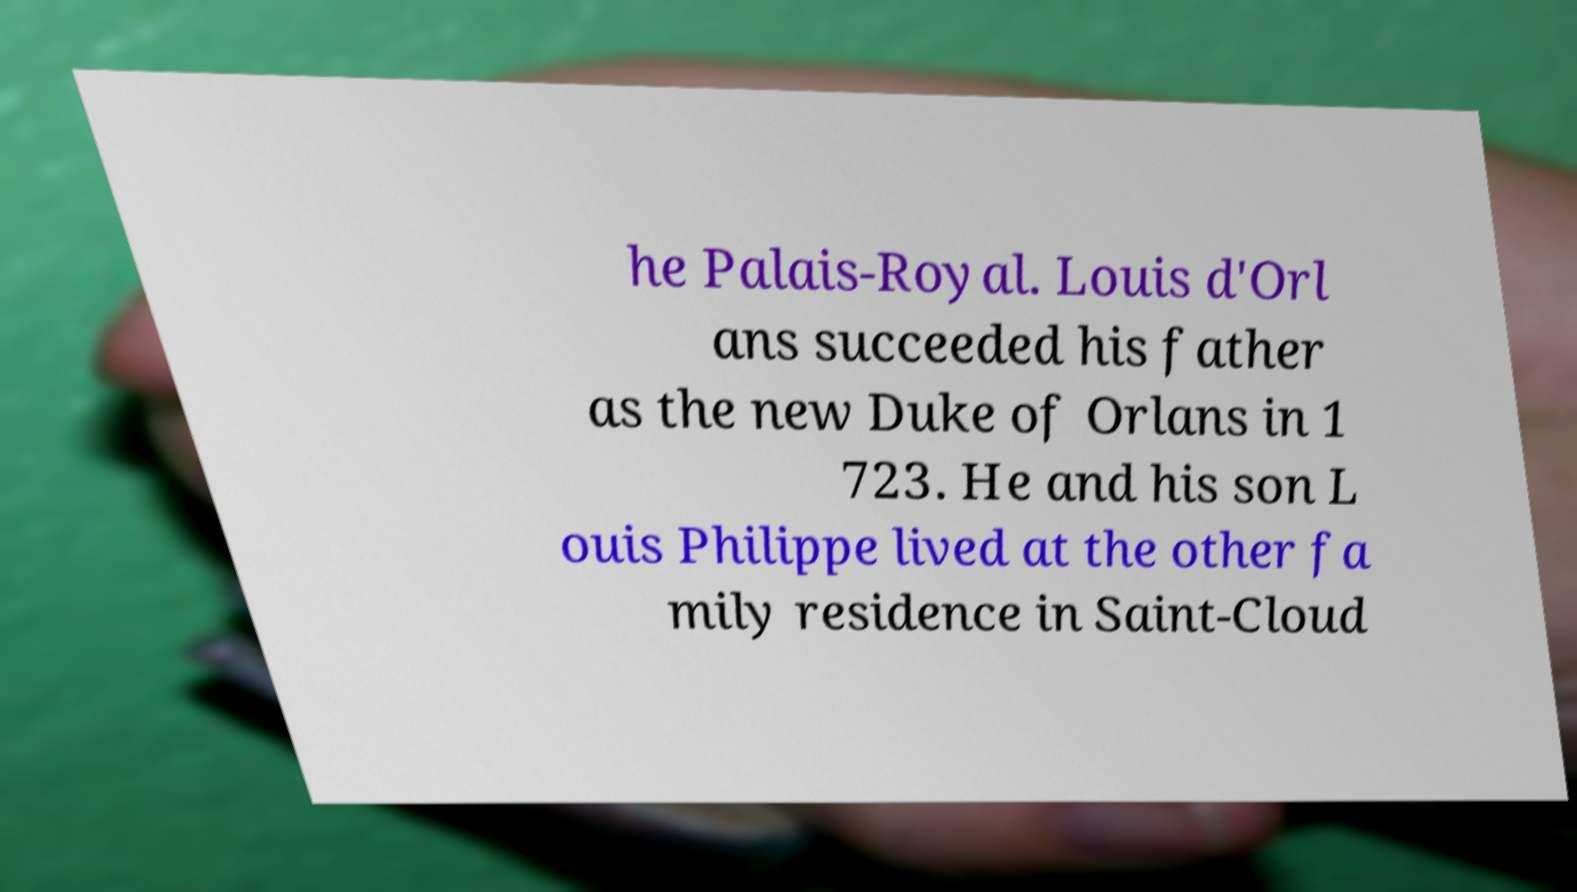Can you accurately transcribe the text from the provided image for me? he Palais-Royal. Louis d'Orl ans succeeded his father as the new Duke of Orlans in 1 723. He and his son L ouis Philippe lived at the other fa mily residence in Saint-Cloud 